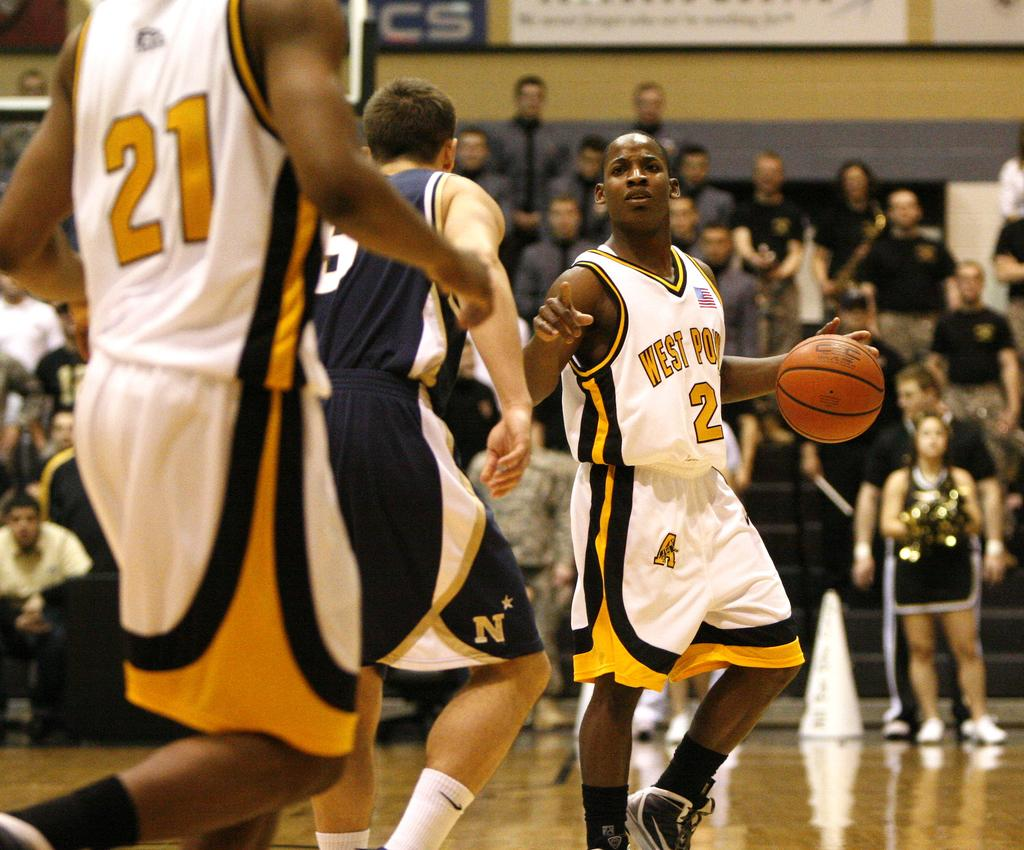Provide a one-sentence caption for the provided image. Player number 2 currently has the basketball, and player 21 is nearby. 